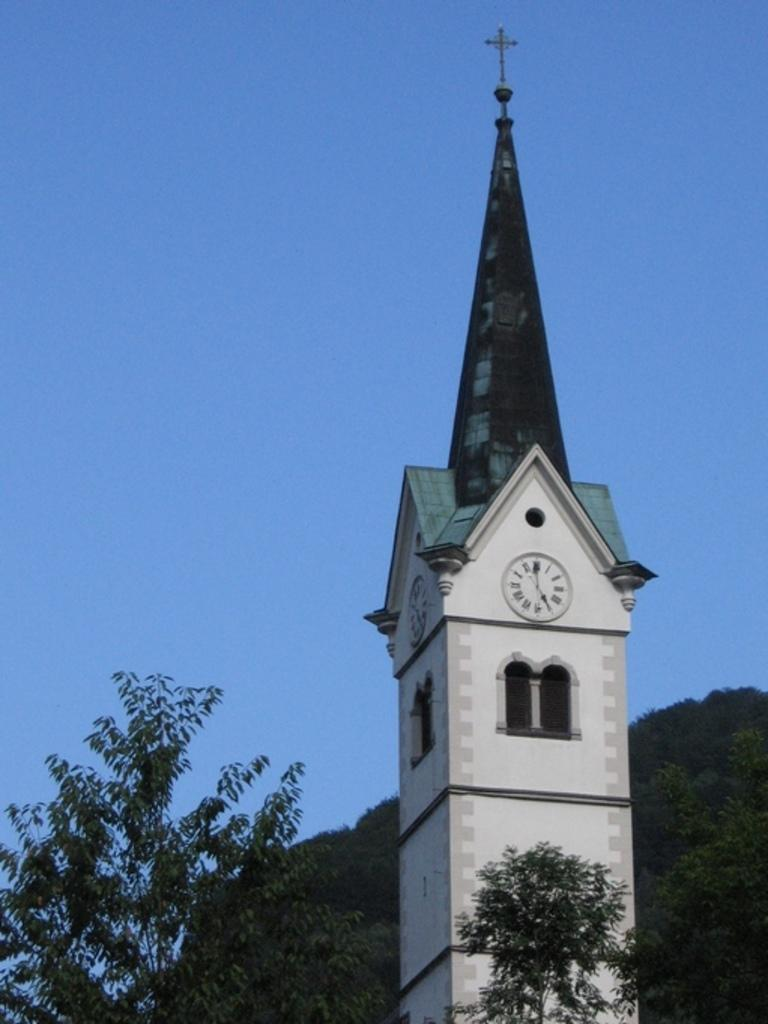What is the main structure in the image? There is a clock tower in the image. What type of vegetation can be seen in the image? There are trees in the image. What can be seen in the background of the image? The sky is visible in the background of the image. Where is the mine located in the image? There is no mine present in the image. What type of spider web can be seen on the clock tower in the image? There is no spider web, or cobweb, present on the clock tower in the image. 